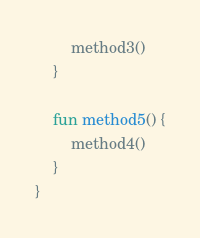<code> <loc_0><loc_0><loc_500><loc_500><_Kotlin_>        method3()
    }

    fun method5() {
        method4()
    }
}
</code> 